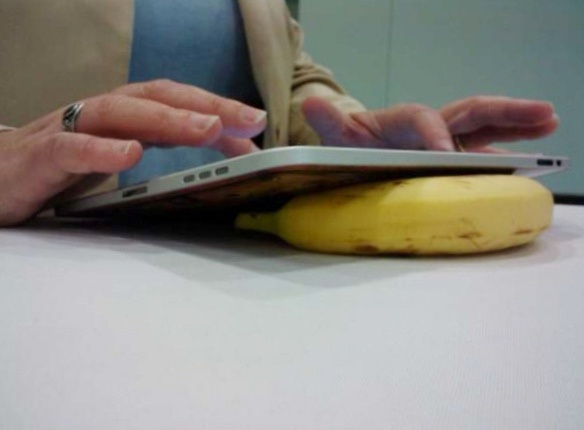Describe the objects in this image and their specific colors. I can see people in gray, brown, maroon, and black tones and banana in gray, tan, olive, and black tones in this image. 